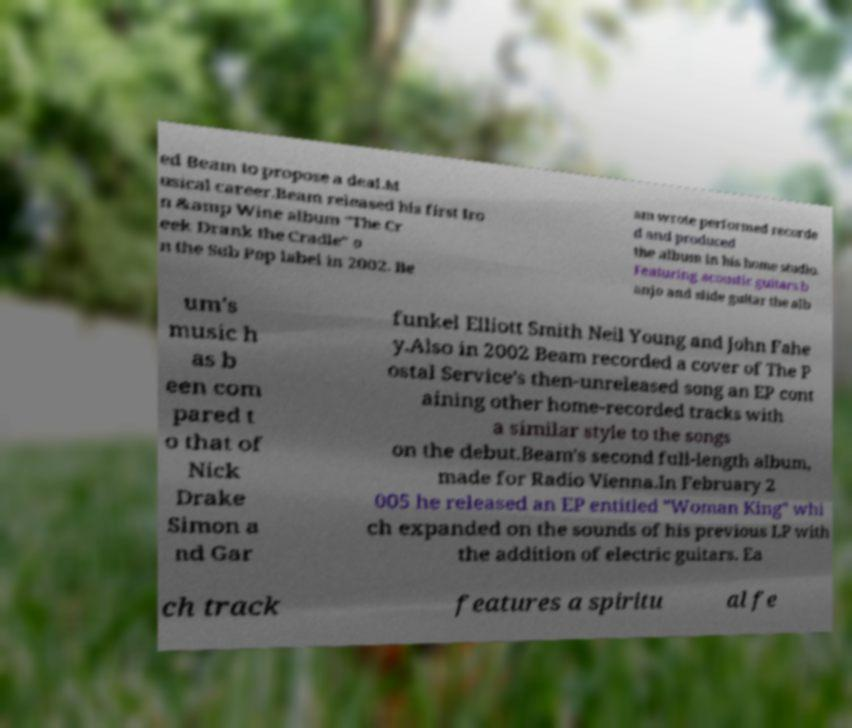Can you accurately transcribe the text from the provided image for me? ed Beam to propose a deal.M usical career.Beam released his first Iro n &amp Wine album "The Cr eek Drank the Cradle" o n the Sub Pop label in 2002. Be am wrote performed recorde d and produced the album in his home studio. Featuring acoustic guitars b anjo and slide guitar the alb um's music h as b een com pared t o that of Nick Drake Simon a nd Gar funkel Elliott Smith Neil Young and John Fahe y.Also in 2002 Beam recorded a cover of The P ostal Service's then-unreleased song an EP cont aining other home-recorded tracks with a similar style to the songs on the debut.Beam's second full-length album, made for Radio Vienna.In February 2 005 he released an EP entitled "Woman King" whi ch expanded on the sounds of his previous LP with the addition of electric guitars. Ea ch track features a spiritu al fe 